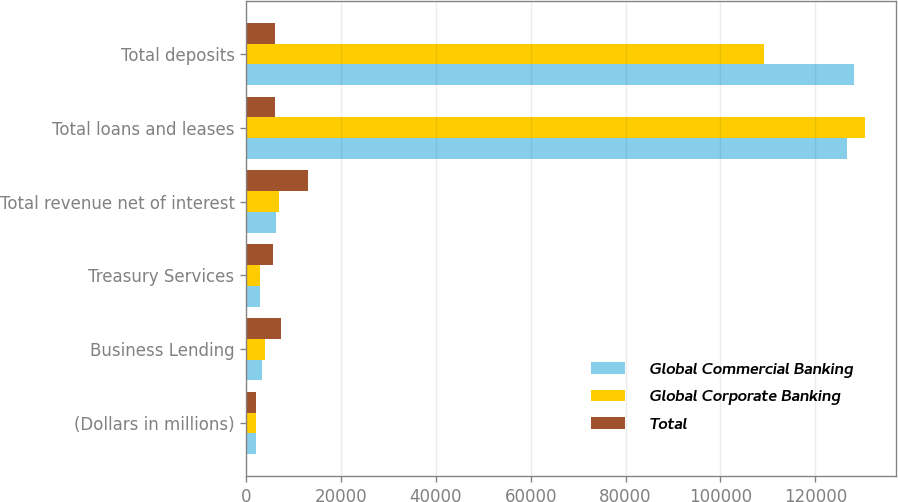<chart> <loc_0><loc_0><loc_500><loc_500><stacked_bar_chart><ecel><fcel>(Dollars in millions)<fcel>Business Lending<fcel>Treasury Services<fcel>Total revenue net of interest<fcel>Total loans and leases<fcel>Total deposits<nl><fcel>Global Commercial Banking<fcel>2013<fcel>3407<fcel>2815<fcel>6222<fcel>126669<fcel>128198<nl><fcel>Global Corporate Banking<fcel>2013<fcel>3967<fcel>2939<fcel>6906<fcel>130563<fcel>109225<nl><fcel>Total<fcel>2013<fcel>7374<fcel>5754<fcel>13128<fcel>5988<fcel>5988<nl></chart> 